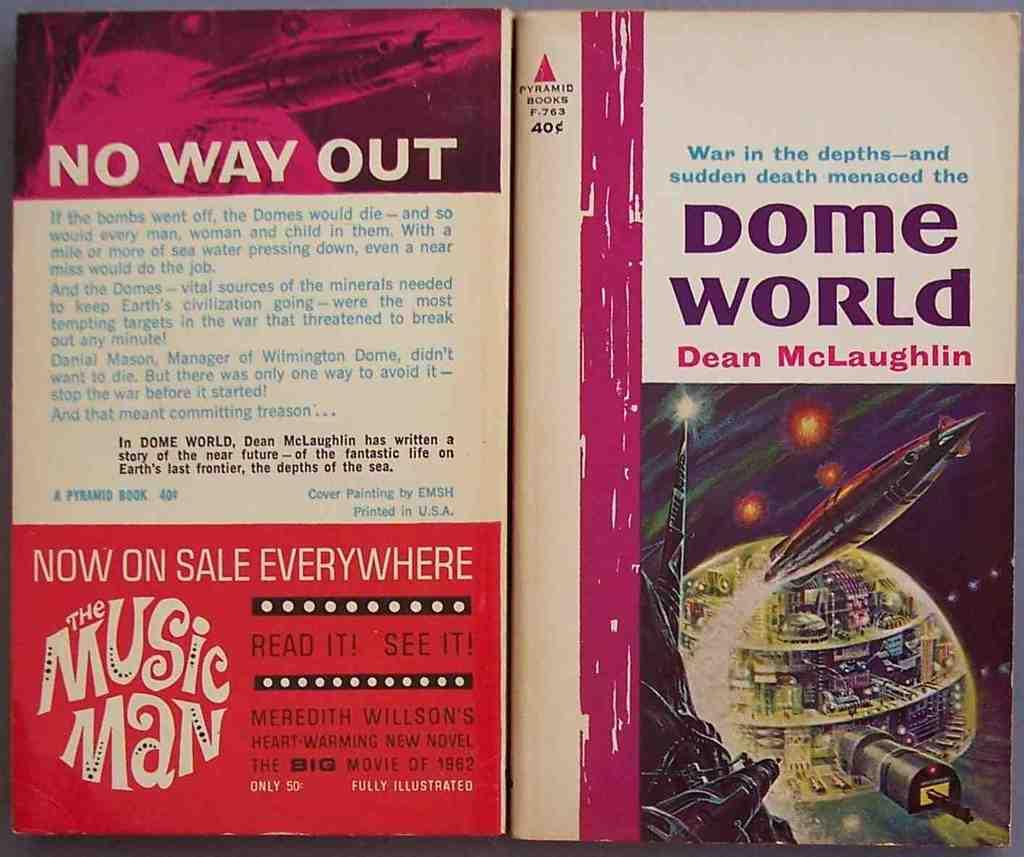<image>
Provide a brief description of the given image. Dean McLaughlin wrote a book called Dome World 